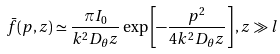<formula> <loc_0><loc_0><loc_500><loc_500>\bar { f } ( { p } , z ) \simeq \frac { \pi I _ { 0 } } { k ^ { 2 } D _ { \theta } z } \exp \left [ - \frac { p ^ { 2 } } { 4 k ^ { 2 } D _ { \theta } z } \right ] , z \gg l</formula> 